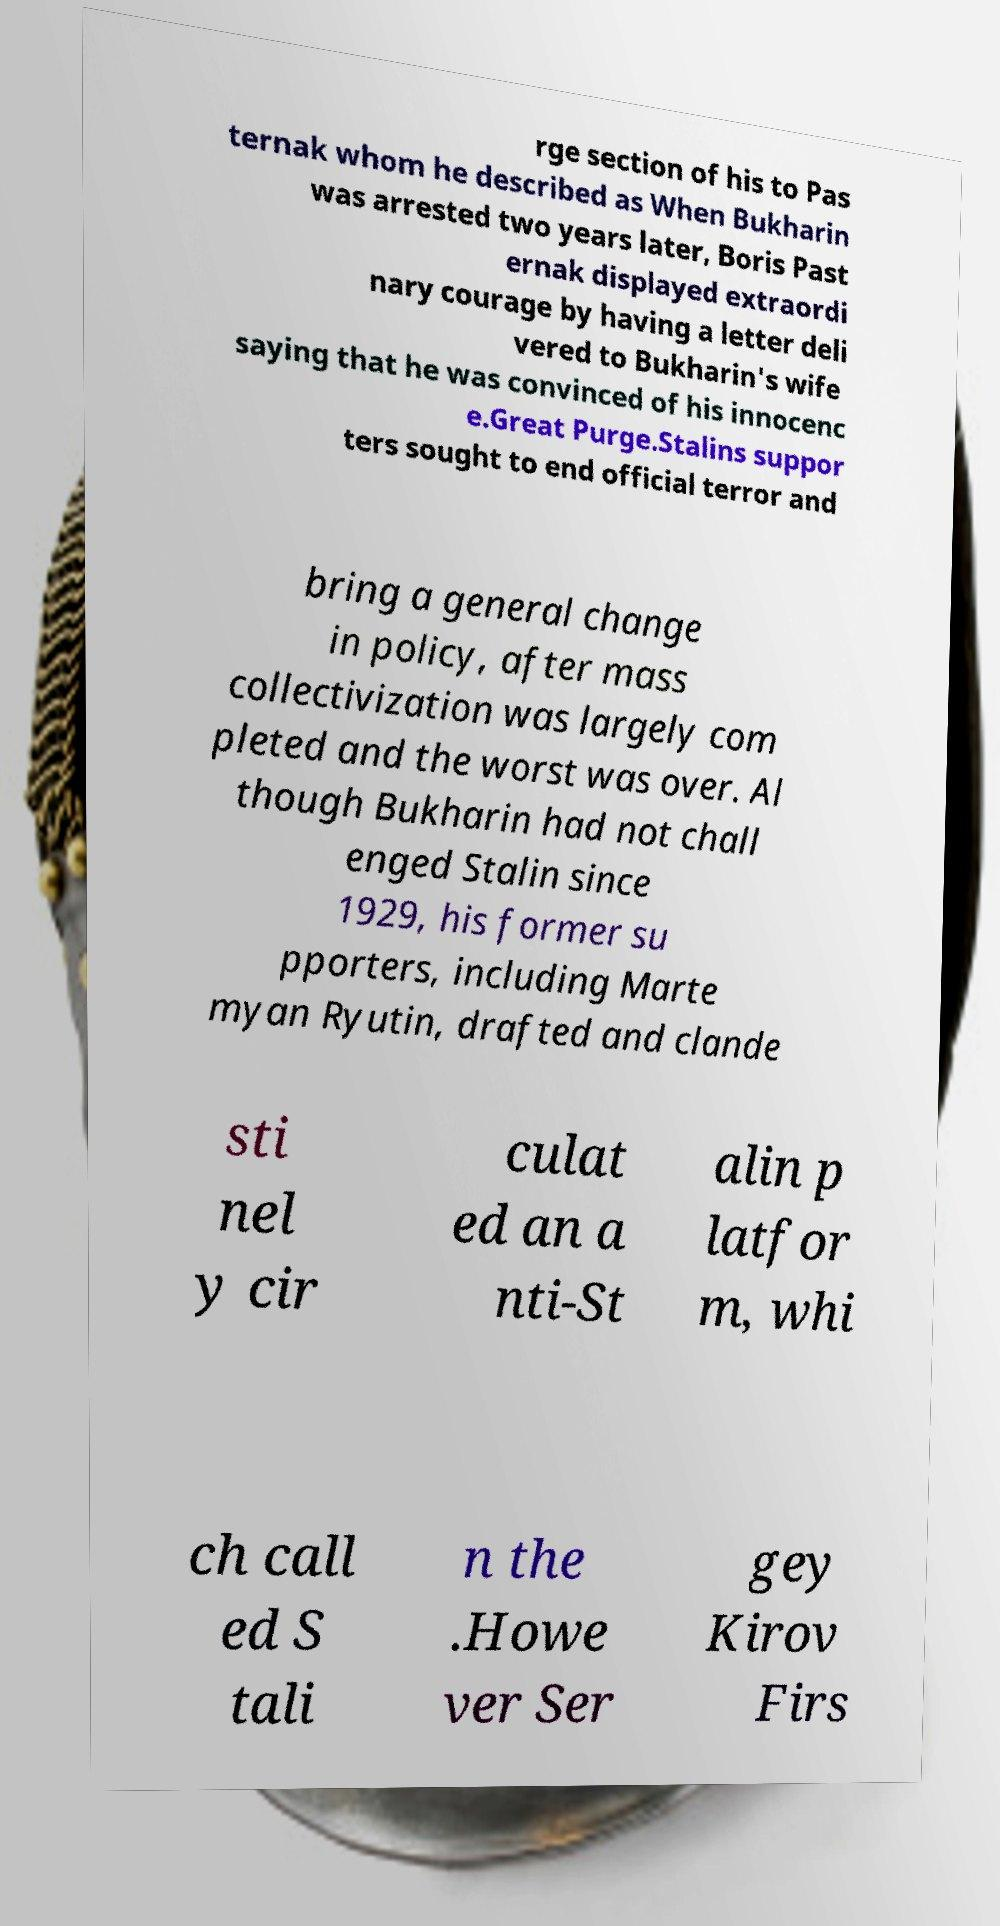Can you read and provide the text displayed in the image?This photo seems to have some interesting text. Can you extract and type it out for me? rge section of his to Pas ternak whom he described as When Bukharin was arrested two years later, Boris Past ernak displayed extraordi nary courage by having a letter deli vered to Bukharin's wife saying that he was convinced of his innocenc e.Great Purge.Stalins suppor ters sought to end official terror and bring a general change in policy, after mass collectivization was largely com pleted and the worst was over. Al though Bukharin had not chall enged Stalin since 1929, his former su pporters, including Marte myan Ryutin, drafted and clande sti nel y cir culat ed an a nti-St alin p latfor m, whi ch call ed S tali n the .Howe ver Ser gey Kirov Firs 